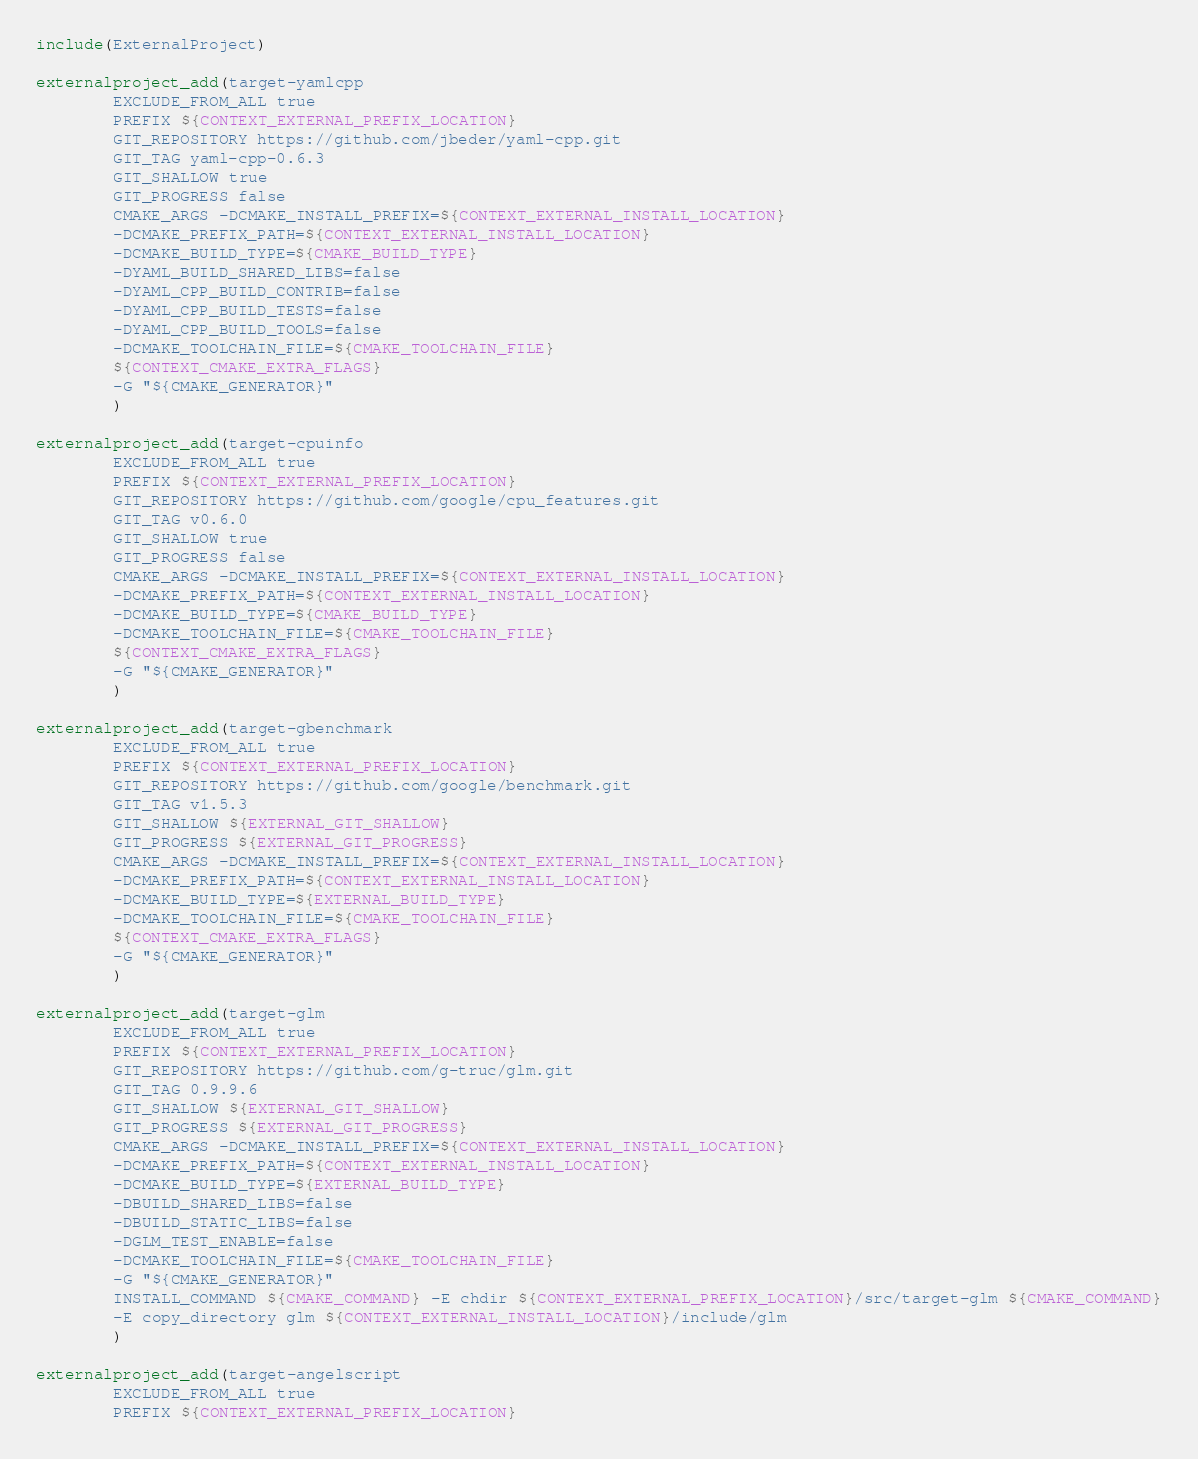<code> <loc_0><loc_0><loc_500><loc_500><_CMake_>include(ExternalProject)

externalproject_add(target-yamlcpp
        EXCLUDE_FROM_ALL true
        PREFIX ${CONTEXT_EXTERNAL_PREFIX_LOCATION}
        GIT_REPOSITORY https://github.com/jbeder/yaml-cpp.git
        GIT_TAG yaml-cpp-0.6.3
        GIT_SHALLOW true
        GIT_PROGRESS false
        CMAKE_ARGS -DCMAKE_INSTALL_PREFIX=${CONTEXT_EXTERNAL_INSTALL_LOCATION}
        -DCMAKE_PREFIX_PATH=${CONTEXT_EXTERNAL_INSTALL_LOCATION}
        -DCMAKE_BUILD_TYPE=${CMAKE_BUILD_TYPE}
        -DYAML_BUILD_SHARED_LIBS=false
        -DYAML_CPP_BUILD_CONTRIB=false
        -DYAML_CPP_BUILD_TESTS=false
        -DYAML_CPP_BUILD_TOOLS=false
        -DCMAKE_TOOLCHAIN_FILE=${CMAKE_TOOLCHAIN_FILE}
        ${CONTEXT_CMAKE_EXTRA_FLAGS}
        -G "${CMAKE_GENERATOR}"
        )

externalproject_add(target-cpuinfo
        EXCLUDE_FROM_ALL true
        PREFIX ${CONTEXT_EXTERNAL_PREFIX_LOCATION}
        GIT_REPOSITORY https://github.com/google/cpu_features.git
        GIT_TAG v0.6.0
        GIT_SHALLOW true
        GIT_PROGRESS false
        CMAKE_ARGS -DCMAKE_INSTALL_PREFIX=${CONTEXT_EXTERNAL_INSTALL_LOCATION}
        -DCMAKE_PREFIX_PATH=${CONTEXT_EXTERNAL_INSTALL_LOCATION}
        -DCMAKE_BUILD_TYPE=${CMAKE_BUILD_TYPE}
        -DCMAKE_TOOLCHAIN_FILE=${CMAKE_TOOLCHAIN_FILE}
        ${CONTEXT_CMAKE_EXTRA_FLAGS}
        -G "${CMAKE_GENERATOR}"
        )

externalproject_add(target-gbenchmark
        EXCLUDE_FROM_ALL true
        PREFIX ${CONTEXT_EXTERNAL_PREFIX_LOCATION}
        GIT_REPOSITORY https://github.com/google/benchmark.git
        GIT_TAG v1.5.3
        GIT_SHALLOW ${EXTERNAL_GIT_SHALLOW}
        GIT_PROGRESS ${EXTERNAL_GIT_PROGRESS}
        CMAKE_ARGS -DCMAKE_INSTALL_PREFIX=${CONTEXT_EXTERNAL_INSTALL_LOCATION}
        -DCMAKE_PREFIX_PATH=${CONTEXT_EXTERNAL_INSTALL_LOCATION}
        -DCMAKE_BUILD_TYPE=${EXTERNAL_BUILD_TYPE}
        -DCMAKE_TOOLCHAIN_FILE=${CMAKE_TOOLCHAIN_FILE}
        ${CONTEXT_CMAKE_EXTRA_FLAGS}
        -G "${CMAKE_GENERATOR}"
        )

externalproject_add(target-glm
        EXCLUDE_FROM_ALL true
        PREFIX ${CONTEXT_EXTERNAL_PREFIX_LOCATION}
        GIT_REPOSITORY https://github.com/g-truc/glm.git
        GIT_TAG 0.9.9.6
        GIT_SHALLOW ${EXTERNAL_GIT_SHALLOW}
        GIT_PROGRESS ${EXTERNAL_GIT_PROGRESS}
        CMAKE_ARGS -DCMAKE_INSTALL_PREFIX=${CONTEXT_EXTERNAL_INSTALL_LOCATION}
        -DCMAKE_PREFIX_PATH=${CONTEXT_EXTERNAL_INSTALL_LOCATION}
        -DCMAKE_BUILD_TYPE=${EXTERNAL_BUILD_TYPE}
        -DBUILD_SHARED_LIBS=false
        -DBUILD_STATIC_LIBS=false
        -DGLM_TEST_ENABLE=false
        -DCMAKE_TOOLCHAIN_FILE=${CMAKE_TOOLCHAIN_FILE}
        -G "${CMAKE_GENERATOR}"
        INSTALL_COMMAND ${CMAKE_COMMAND} -E chdir ${CONTEXT_EXTERNAL_PREFIX_LOCATION}/src/target-glm ${CMAKE_COMMAND}
        -E copy_directory glm ${CONTEXT_EXTERNAL_INSTALL_LOCATION}/include/glm
        )

externalproject_add(target-angelscript
        EXCLUDE_FROM_ALL true
        PREFIX ${CONTEXT_EXTERNAL_PREFIX_LOCATION}</code> 